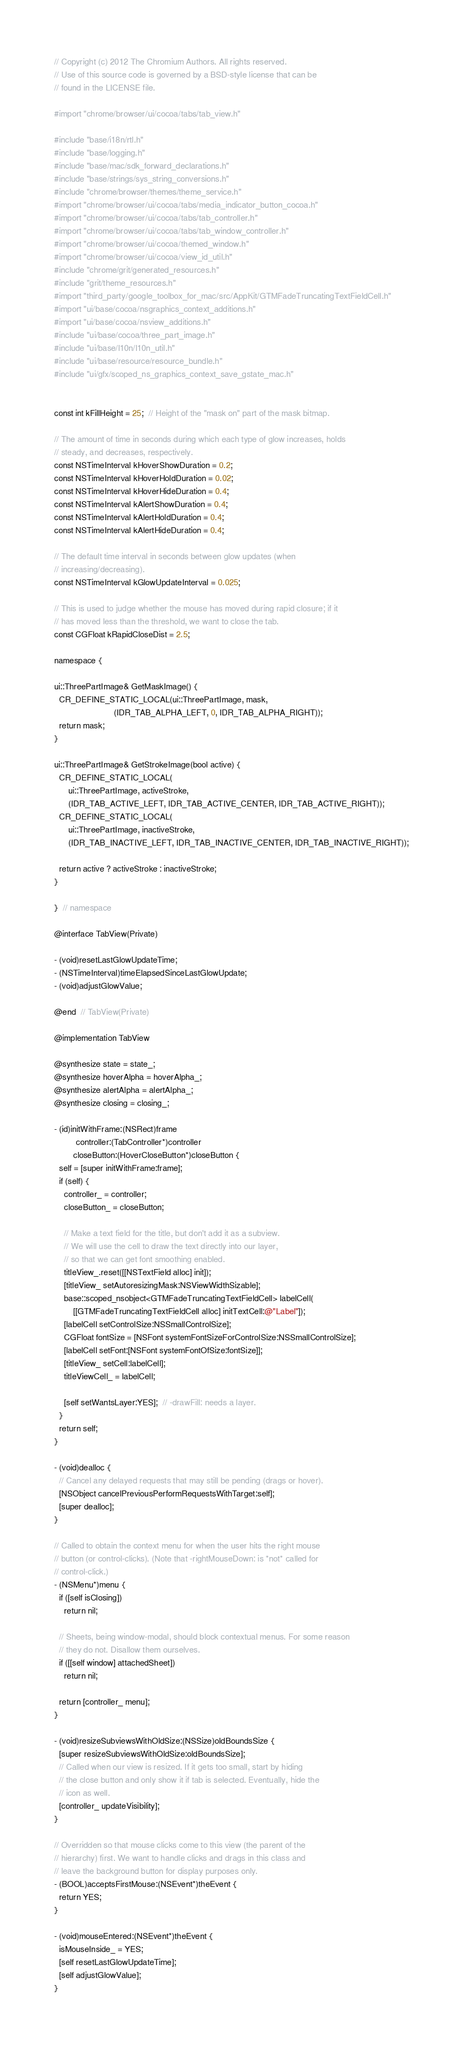<code> <loc_0><loc_0><loc_500><loc_500><_ObjectiveC_>// Copyright (c) 2012 The Chromium Authors. All rights reserved.
// Use of this source code is governed by a BSD-style license that can be
// found in the LICENSE file.

#import "chrome/browser/ui/cocoa/tabs/tab_view.h"

#include "base/i18n/rtl.h"
#include "base/logging.h"
#include "base/mac/sdk_forward_declarations.h"
#include "base/strings/sys_string_conversions.h"
#include "chrome/browser/themes/theme_service.h"
#import "chrome/browser/ui/cocoa/tabs/media_indicator_button_cocoa.h"
#import "chrome/browser/ui/cocoa/tabs/tab_controller.h"
#import "chrome/browser/ui/cocoa/tabs/tab_window_controller.h"
#import "chrome/browser/ui/cocoa/themed_window.h"
#import "chrome/browser/ui/cocoa/view_id_util.h"
#include "chrome/grit/generated_resources.h"
#include "grit/theme_resources.h"
#import "third_party/google_toolbox_for_mac/src/AppKit/GTMFadeTruncatingTextFieldCell.h"
#import "ui/base/cocoa/nsgraphics_context_additions.h"
#import "ui/base/cocoa/nsview_additions.h"
#include "ui/base/cocoa/three_part_image.h"
#include "ui/base/l10n/l10n_util.h"
#include "ui/base/resource/resource_bundle.h"
#include "ui/gfx/scoped_ns_graphics_context_save_gstate_mac.h"


const int kFillHeight = 25;  // Height of the "mask on" part of the mask bitmap.

// The amount of time in seconds during which each type of glow increases, holds
// steady, and decreases, respectively.
const NSTimeInterval kHoverShowDuration = 0.2;
const NSTimeInterval kHoverHoldDuration = 0.02;
const NSTimeInterval kHoverHideDuration = 0.4;
const NSTimeInterval kAlertShowDuration = 0.4;
const NSTimeInterval kAlertHoldDuration = 0.4;
const NSTimeInterval kAlertHideDuration = 0.4;

// The default time interval in seconds between glow updates (when
// increasing/decreasing).
const NSTimeInterval kGlowUpdateInterval = 0.025;

// This is used to judge whether the mouse has moved during rapid closure; if it
// has moved less than the threshold, we want to close the tab.
const CGFloat kRapidCloseDist = 2.5;

namespace {

ui::ThreePartImage& GetMaskImage() {
  CR_DEFINE_STATIC_LOCAL(ui::ThreePartImage, mask,
                         (IDR_TAB_ALPHA_LEFT, 0, IDR_TAB_ALPHA_RIGHT));
  return mask;
}

ui::ThreePartImage& GetStrokeImage(bool active) {
  CR_DEFINE_STATIC_LOCAL(
      ui::ThreePartImage, activeStroke,
      (IDR_TAB_ACTIVE_LEFT, IDR_TAB_ACTIVE_CENTER, IDR_TAB_ACTIVE_RIGHT));
  CR_DEFINE_STATIC_LOCAL(
      ui::ThreePartImage, inactiveStroke,
      (IDR_TAB_INACTIVE_LEFT, IDR_TAB_INACTIVE_CENTER, IDR_TAB_INACTIVE_RIGHT));

  return active ? activeStroke : inactiveStroke;
}

}  // namespace

@interface TabView(Private)

- (void)resetLastGlowUpdateTime;
- (NSTimeInterval)timeElapsedSinceLastGlowUpdate;
- (void)adjustGlowValue;

@end  // TabView(Private)

@implementation TabView

@synthesize state = state_;
@synthesize hoverAlpha = hoverAlpha_;
@synthesize alertAlpha = alertAlpha_;
@synthesize closing = closing_;

- (id)initWithFrame:(NSRect)frame
         controller:(TabController*)controller
        closeButton:(HoverCloseButton*)closeButton {
  self = [super initWithFrame:frame];
  if (self) {
    controller_ = controller;
    closeButton_ = closeButton;

    // Make a text field for the title, but don't add it as a subview.
    // We will use the cell to draw the text directly into our layer,
    // so that we can get font smoothing enabled.
    titleView_.reset([[NSTextField alloc] init]);
    [titleView_ setAutoresizingMask:NSViewWidthSizable];
    base::scoped_nsobject<GTMFadeTruncatingTextFieldCell> labelCell(
        [[GTMFadeTruncatingTextFieldCell alloc] initTextCell:@"Label"]);
    [labelCell setControlSize:NSSmallControlSize];
    CGFloat fontSize = [NSFont systemFontSizeForControlSize:NSSmallControlSize];
    [labelCell setFont:[NSFont systemFontOfSize:fontSize]];
    [titleView_ setCell:labelCell];
    titleViewCell_ = labelCell;

    [self setWantsLayer:YES];  // -drawFill: needs a layer.
  }
  return self;
}

- (void)dealloc {
  // Cancel any delayed requests that may still be pending (drags or hover).
  [NSObject cancelPreviousPerformRequestsWithTarget:self];
  [super dealloc];
}

// Called to obtain the context menu for when the user hits the right mouse
// button (or control-clicks). (Note that -rightMouseDown: is *not* called for
// control-click.)
- (NSMenu*)menu {
  if ([self isClosing])
    return nil;

  // Sheets, being window-modal, should block contextual menus. For some reason
  // they do not. Disallow them ourselves.
  if ([[self window] attachedSheet])
    return nil;

  return [controller_ menu];
}

- (void)resizeSubviewsWithOldSize:(NSSize)oldBoundsSize {
  [super resizeSubviewsWithOldSize:oldBoundsSize];
  // Called when our view is resized. If it gets too small, start by hiding
  // the close button and only show it if tab is selected. Eventually, hide the
  // icon as well.
  [controller_ updateVisibility];
}

// Overridden so that mouse clicks come to this view (the parent of the
// hierarchy) first. We want to handle clicks and drags in this class and
// leave the background button for display purposes only.
- (BOOL)acceptsFirstMouse:(NSEvent*)theEvent {
  return YES;
}

- (void)mouseEntered:(NSEvent*)theEvent {
  isMouseInside_ = YES;
  [self resetLastGlowUpdateTime];
  [self adjustGlowValue];
}
</code> 